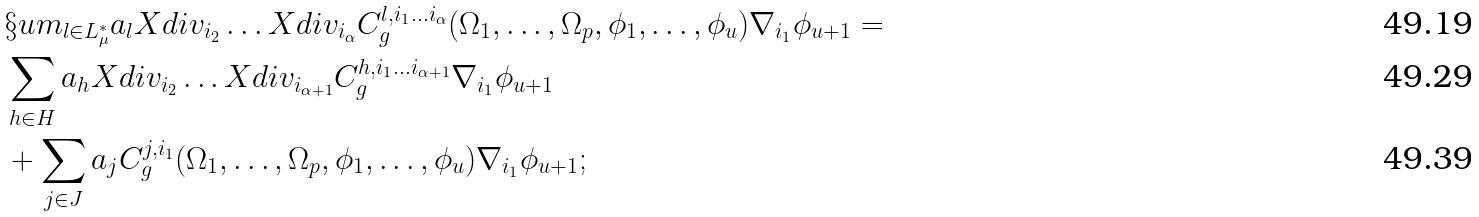Convert formula to latex. <formula><loc_0><loc_0><loc_500><loc_500>& \S u m _ { l \in L _ { \mu } ^ { * } } a _ { l } X d i v _ { i _ { 2 } } \dots X d i v _ { i _ { \alpha } } C ^ { l , i _ { 1 } \dots i _ { \alpha } } _ { g } ( \Omega _ { 1 } , \dots , \Omega _ { p } , \phi _ { 1 } , \dots , \phi _ { u } ) \nabla _ { i _ { 1 } } \phi _ { u + 1 } = \\ & \sum _ { h \in H } a _ { h } X d i v _ { i _ { 2 } } \dots X d i v _ { i _ { \alpha + 1 } } C ^ { h , i _ { 1 } \dots i _ { \alpha + 1 } } _ { g } \nabla _ { i _ { 1 } } \phi _ { u + 1 } \\ & + \sum _ { j \in J } a _ { j } C ^ { j , i _ { 1 } } _ { g } ( \Omega _ { 1 } , \dots , \Omega _ { p } , \phi _ { 1 } , \dots , \phi _ { u } ) \nabla _ { i _ { 1 } } \phi _ { u + 1 } ;</formula> 